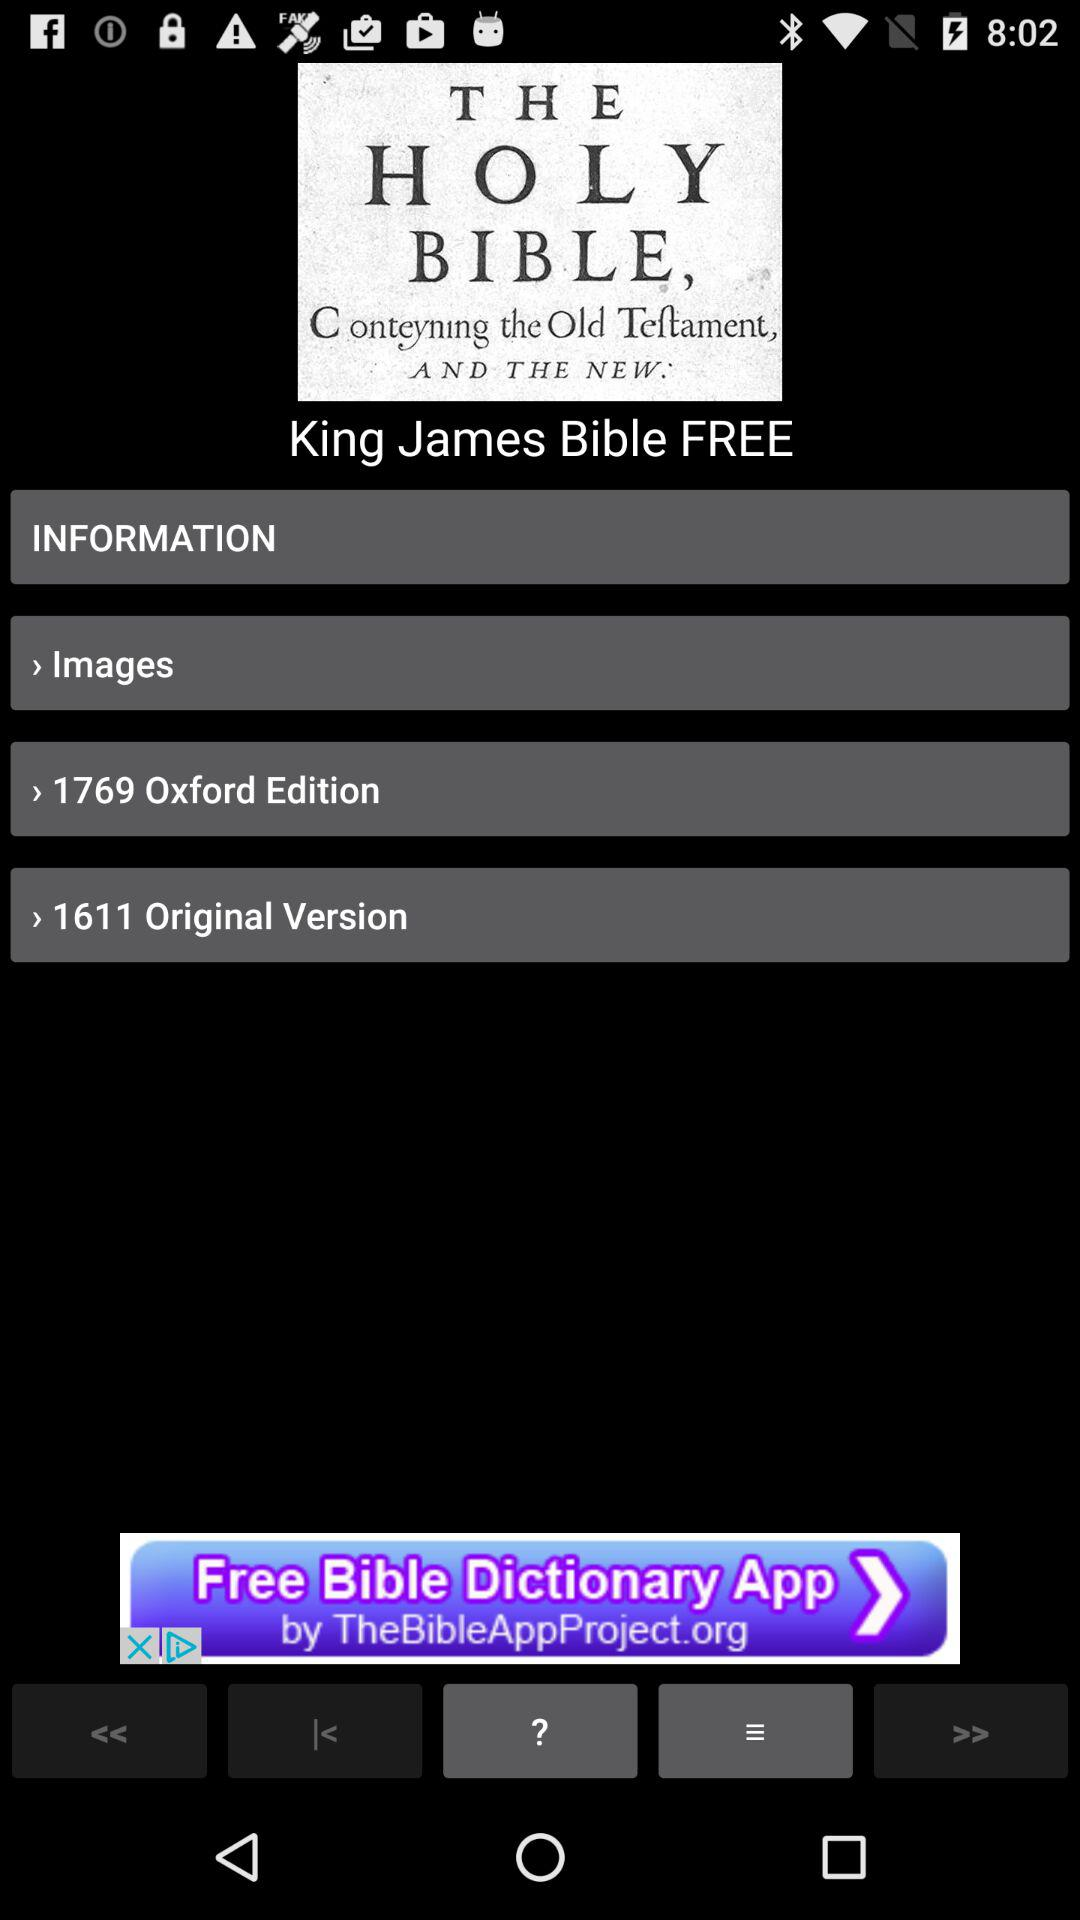What is the original version number? The original version number is 1611. 